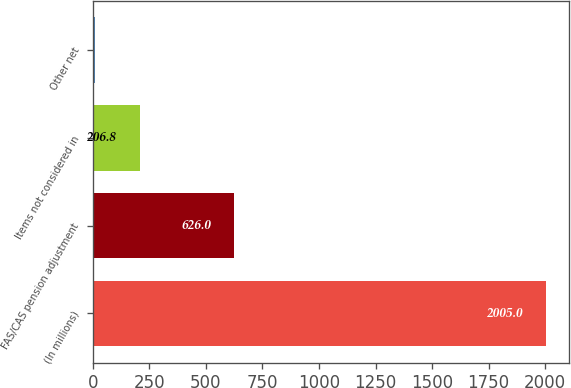<chart> <loc_0><loc_0><loc_500><loc_500><bar_chart><fcel>(In millions)<fcel>FAS/CAS pension adjustment<fcel>Items not considered in<fcel>Other net<nl><fcel>2005<fcel>626<fcel>206.8<fcel>7<nl></chart> 